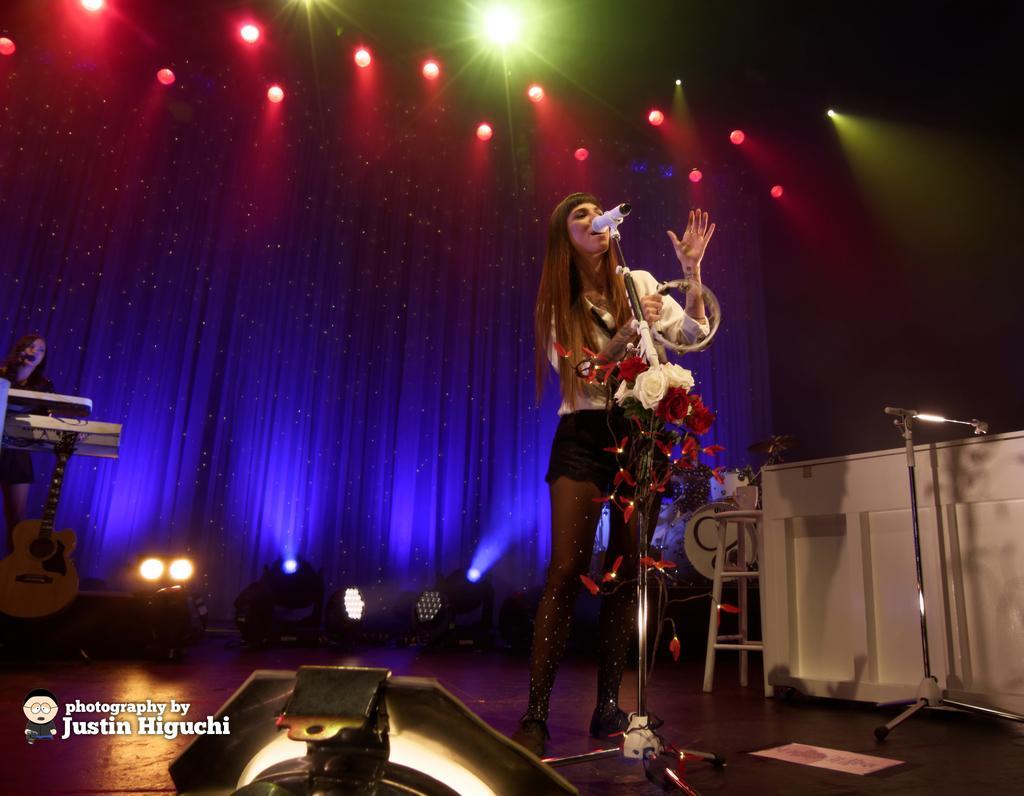Please provide a concise description of this image. As we can see in the image there is a woman singing a song on mike and on the top there are lights. 